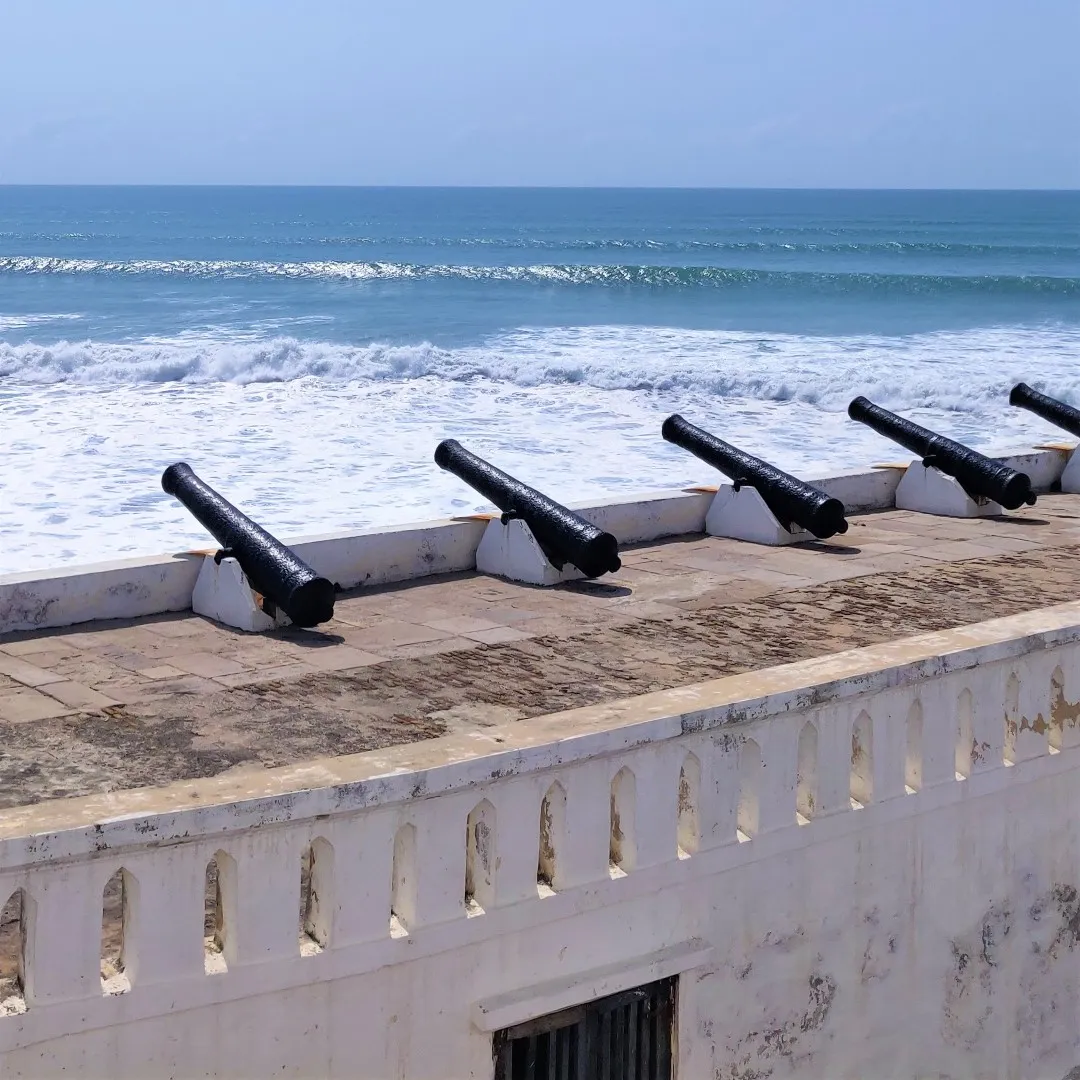Write a detailed description of the given image. The image captures a striking view along the Cape Coast in Ghana, observed from a high vantage point. Prominently featured in the foreground is a row of historical black cannons resting atop a white weathered fortification wall. These centuries-old artifacts are remnants of a significant past, pointed steadfastly towards the vast, endless expanse of the Atlantic Ocean. The deep, profound blue of the ocean sharply contrasts with the pristine whiteness of the wall, as rhythmic waves crash against the shore — their ceaseless motion providing a mesmerizing backdrop. Above, the sky is a vast canvas of clear blue, bathed in the radiant glow of the sun, enhancing the serene yet historic ambiance of the scene. The image skillfully captures the essence of both the historical gravity and the natural beauty of the Cape Coast, as the cannons appear to stand vigilant, symbolically guarding against the perpetually advancing waves. 